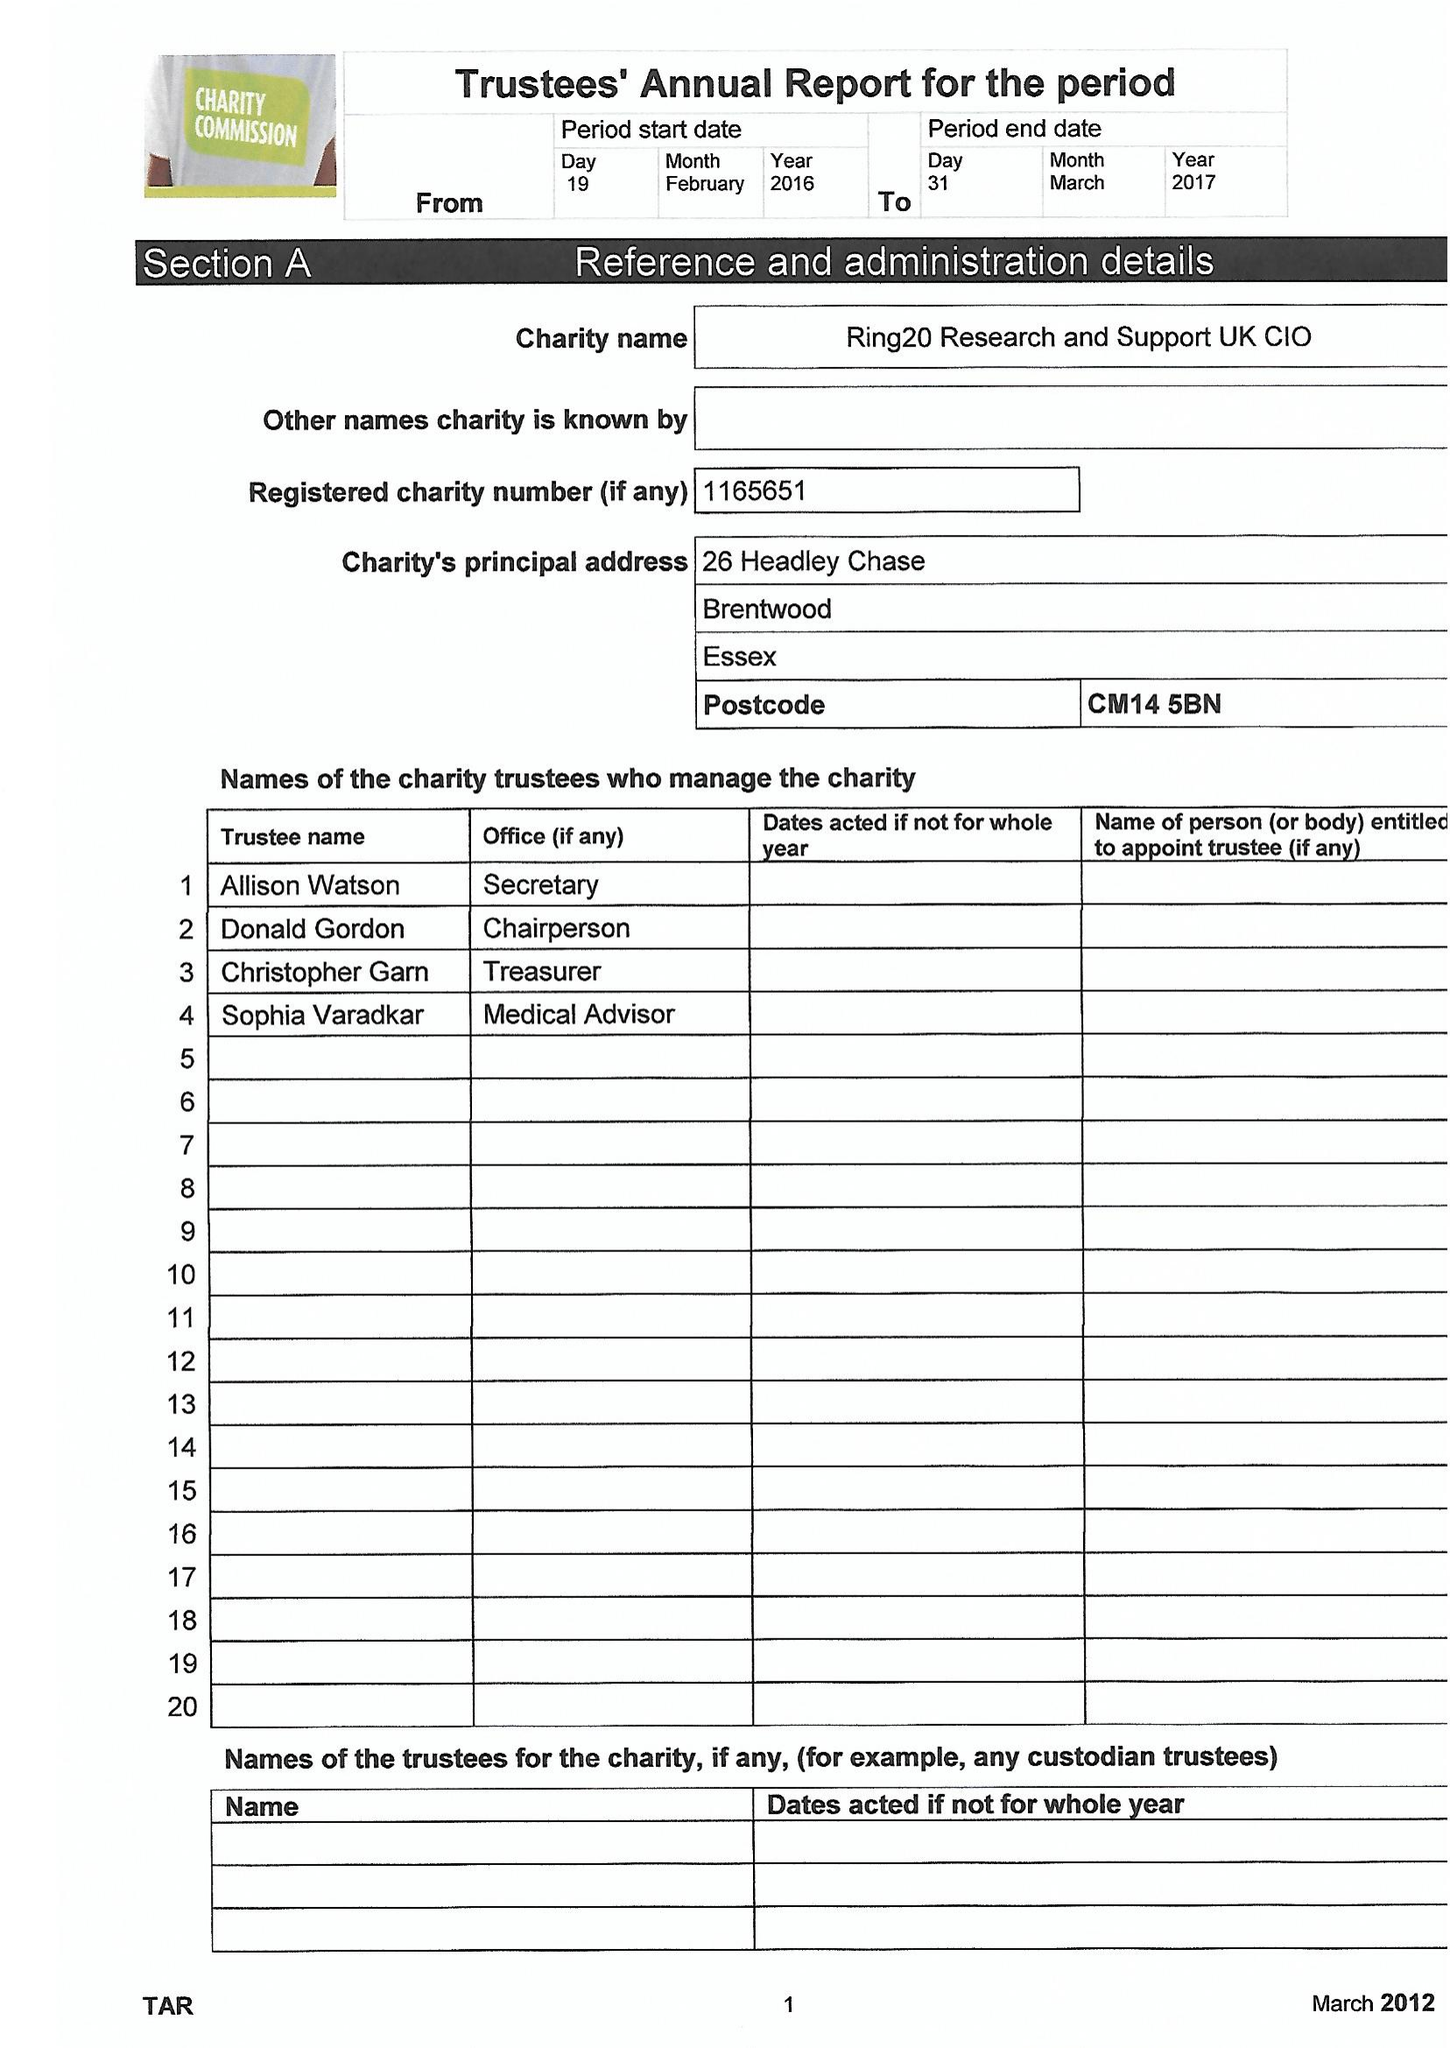What is the value for the address__street_line?
Answer the question using a single word or phrase. 26 HEADLEY CHASE 